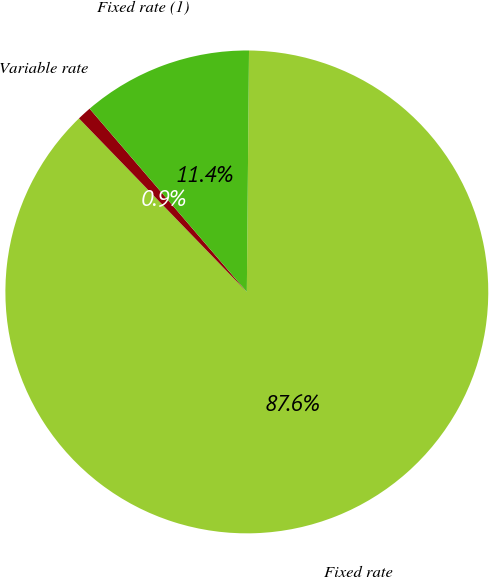<chart> <loc_0><loc_0><loc_500><loc_500><pie_chart><fcel>Fixed rate<fcel>Variable rate<fcel>Fixed rate (1)<nl><fcel>87.62%<fcel>0.95%<fcel>11.43%<nl></chart> 